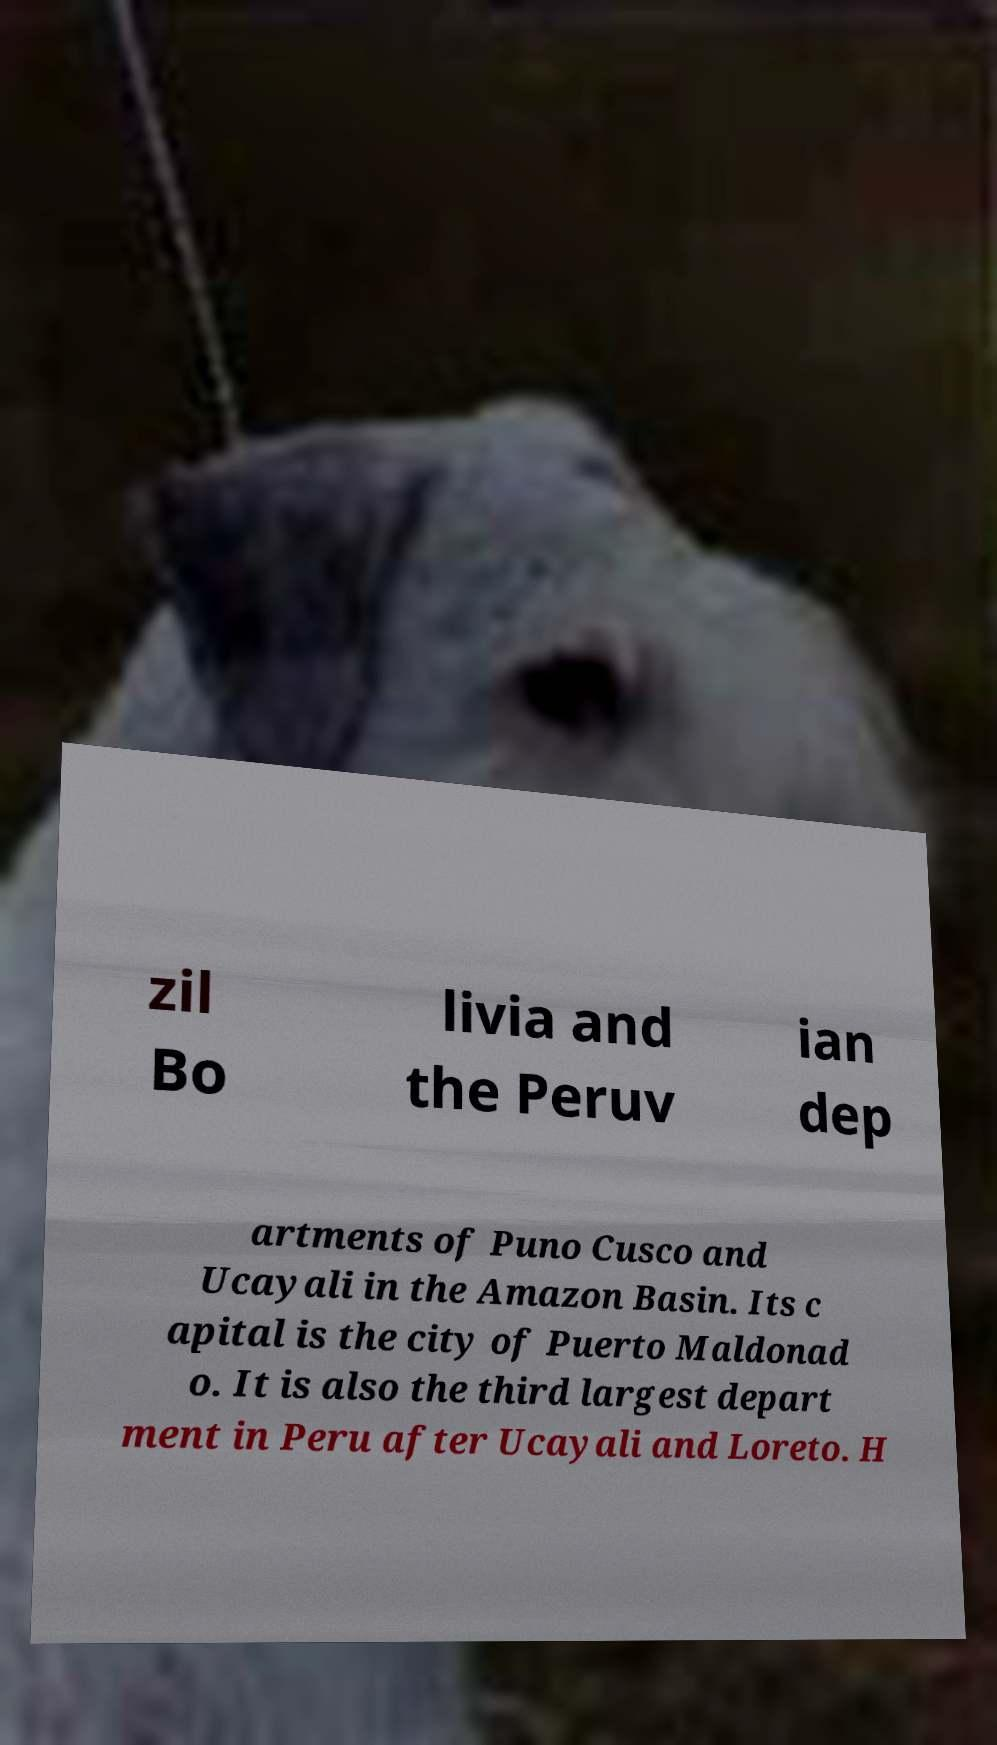I need the written content from this picture converted into text. Can you do that? zil Bo livia and the Peruv ian dep artments of Puno Cusco and Ucayali in the Amazon Basin. Its c apital is the city of Puerto Maldonad o. It is also the third largest depart ment in Peru after Ucayali and Loreto. H 